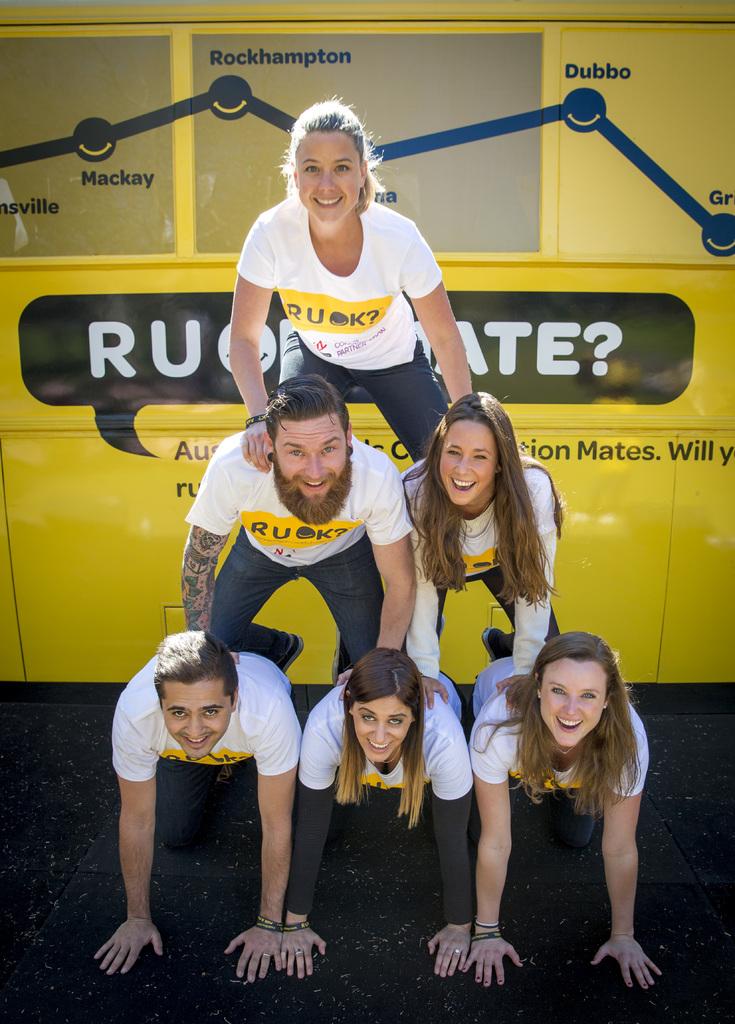What do the peoples' shirts say?
Provide a succinct answer. Ruok. 